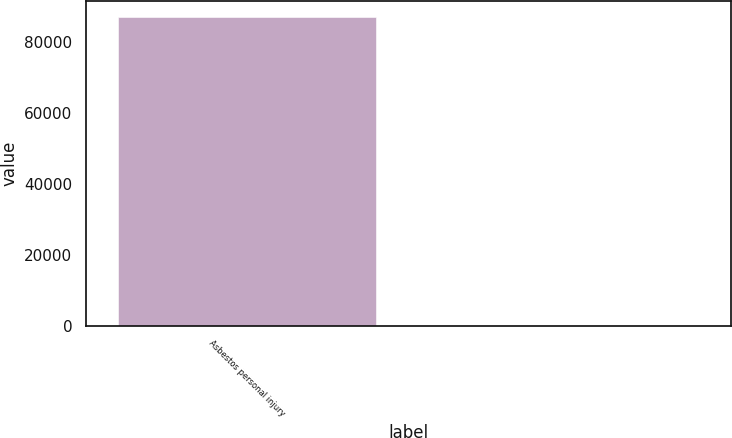<chart> <loc_0><loc_0><loc_500><loc_500><bar_chart><fcel>Asbestos personal injury<fcel>Unnamed: 1<nl><fcel>87070<fcel>35.5<nl></chart> 